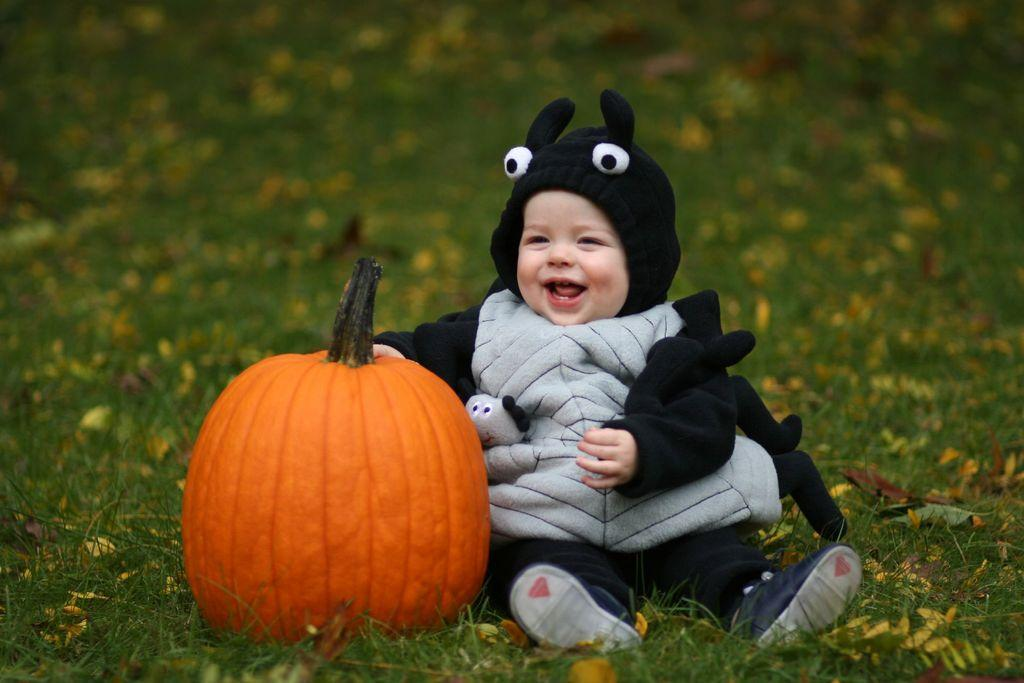What is the main subject of the picture? The main subject of the picture is a kid. How is the kid dressed in the picture? The kid is wearing a fancy dress in the picture. Where is the kid sitting in the picture? The kid is sitting on a greenery ground in the picture. What other object can be seen in the picture? There is a pumpkin in the picture. What is the color of the pumpkin? The pumpkin is orange in color. How is the pumpkin positioned in relation to the kid? The pumpkin is beside the kid in the picture. What type of tools does the carpenter use to fix the hole in the picture? There is no carpenter or hole present in the image; it features a kid sitting on a greenery ground with a pumpkin beside them. 